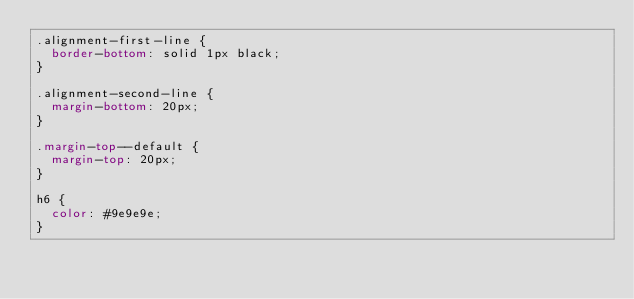Convert code to text. <code><loc_0><loc_0><loc_500><loc_500><_CSS_>.alignment-first-line {
  border-bottom: solid 1px black;
}

.alignment-second-line {
  margin-bottom: 20px;
}

.margin-top--default {
  margin-top: 20px;
}

h6 {
  color: #9e9e9e;
}
</code> 